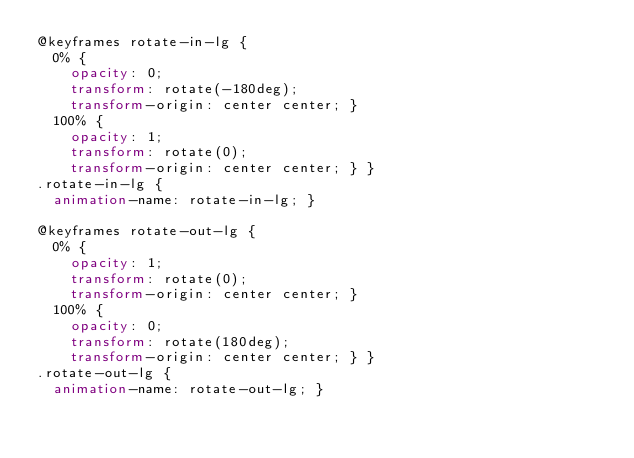<code> <loc_0><loc_0><loc_500><loc_500><_CSS_>@keyframes rotate-in-lg {
  0% {
    opacity: 0;
    transform: rotate(-180deg);
    transform-origin: center center; }
  100% {
    opacity: 1;
    transform: rotate(0);
    transform-origin: center center; } }
.rotate-in-lg {
  animation-name: rotate-in-lg; }

@keyframes rotate-out-lg {
  0% {
    opacity: 1;
    transform: rotate(0);
    transform-origin: center center; }
  100% {
    opacity: 0;
    transform: rotate(180deg);
    transform-origin: center center; } }
.rotate-out-lg {
  animation-name: rotate-out-lg; }
</code> 